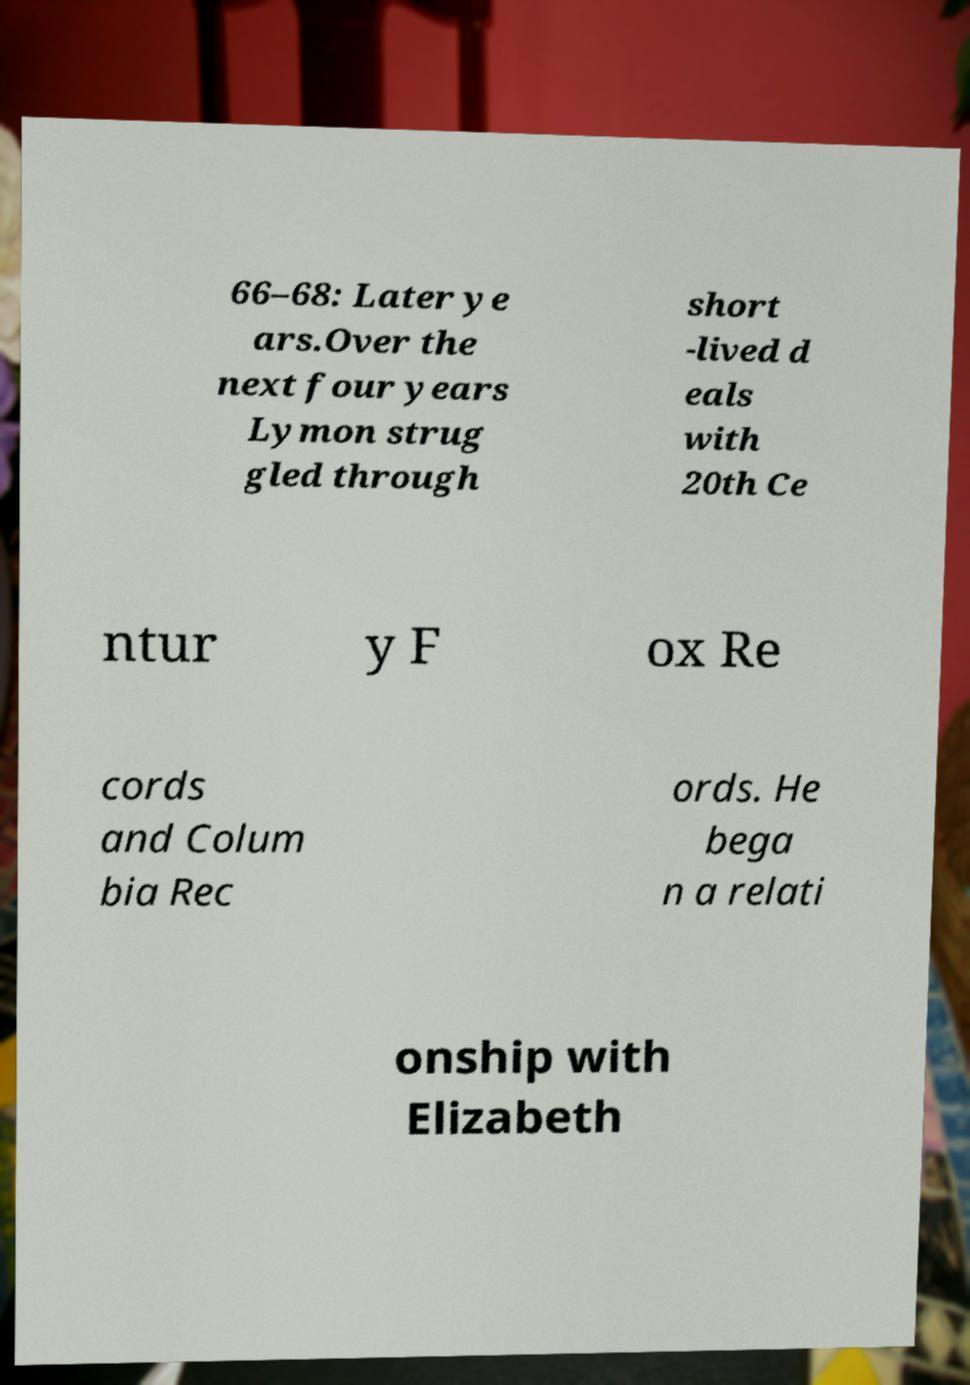Please read and relay the text visible in this image. What does it say? 66–68: Later ye ars.Over the next four years Lymon strug gled through short -lived d eals with 20th Ce ntur y F ox Re cords and Colum bia Rec ords. He bega n a relati onship with Elizabeth 